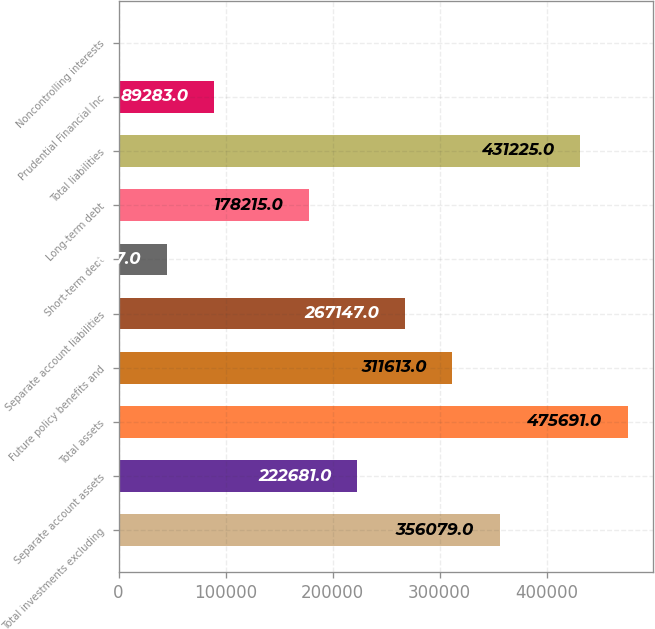Convert chart. <chart><loc_0><loc_0><loc_500><loc_500><bar_chart><fcel>Total investments excluding<fcel>Separate account assets<fcel>Total assets<fcel>Future policy benefits and<fcel>Separate account liabilities<fcel>Short-term debt<fcel>Long-term debt<fcel>Total liabilities<fcel>Prudential Financial Inc<fcel>Noncontrolling interests<nl><fcel>356079<fcel>222681<fcel>475691<fcel>311613<fcel>267147<fcel>44817<fcel>178215<fcel>431225<fcel>89283<fcel>351<nl></chart> 